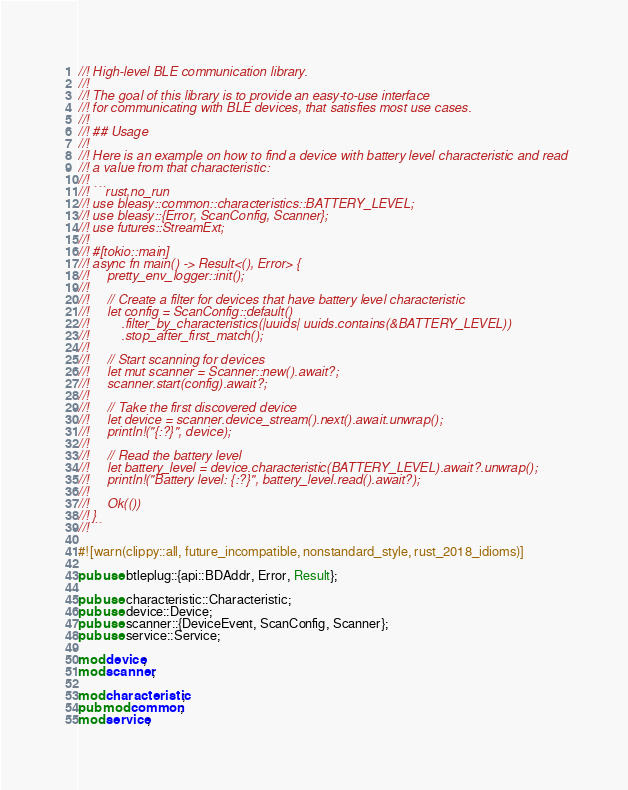<code> <loc_0><loc_0><loc_500><loc_500><_Rust_>//! High-level BLE communication library.
//!
//! The goal of this library is to provide an easy-to-use interface
//! for communicating with BLE devices, that satisfies most use cases.
//!
//! ## Usage
//!
//! Here is an example on how to find a device with battery level characteristic and read
//! a value from that characteristic:
//!
//! ```rust,no_run
//! use bleasy::common::characteristics::BATTERY_LEVEL;
//! use bleasy::{Error, ScanConfig, Scanner};
//! use futures::StreamExt;
//!
//! #[tokio::main]
//! async fn main() -> Result<(), Error> {
//!     pretty_env_logger::init();
//!
//!     // Create a filter for devices that have battery level characteristic
//!     let config = ScanConfig::default()
//!         .filter_by_characteristics(|uuids| uuids.contains(&BATTERY_LEVEL))
//!         .stop_after_first_match();
//!
//!     // Start scanning for devices
//!     let mut scanner = Scanner::new().await?;
//!     scanner.start(config).await?;
//!
//!     // Take the first discovered device
//!     let device = scanner.device_stream().next().await.unwrap();
//!     println!("{:?}", device);
//!
//!     // Read the battery level
//!     let battery_level = device.characteristic(BATTERY_LEVEL).await?.unwrap();
//!     println!("Battery level: {:?}", battery_level.read().await?);
//!
//!     Ok(())
//! }
//!```

#![warn(clippy::all, future_incompatible, nonstandard_style, rust_2018_idioms)]

pub use btleplug::{api::BDAddr, Error, Result};

pub use characteristic::Characteristic;
pub use device::Device;
pub use scanner::{DeviceEvent, ScanConfig, Scanner};
pub use service::Service;

mod device;
mod scanner;

mod characteristic;
pub mod common;
mod service;
</code> 